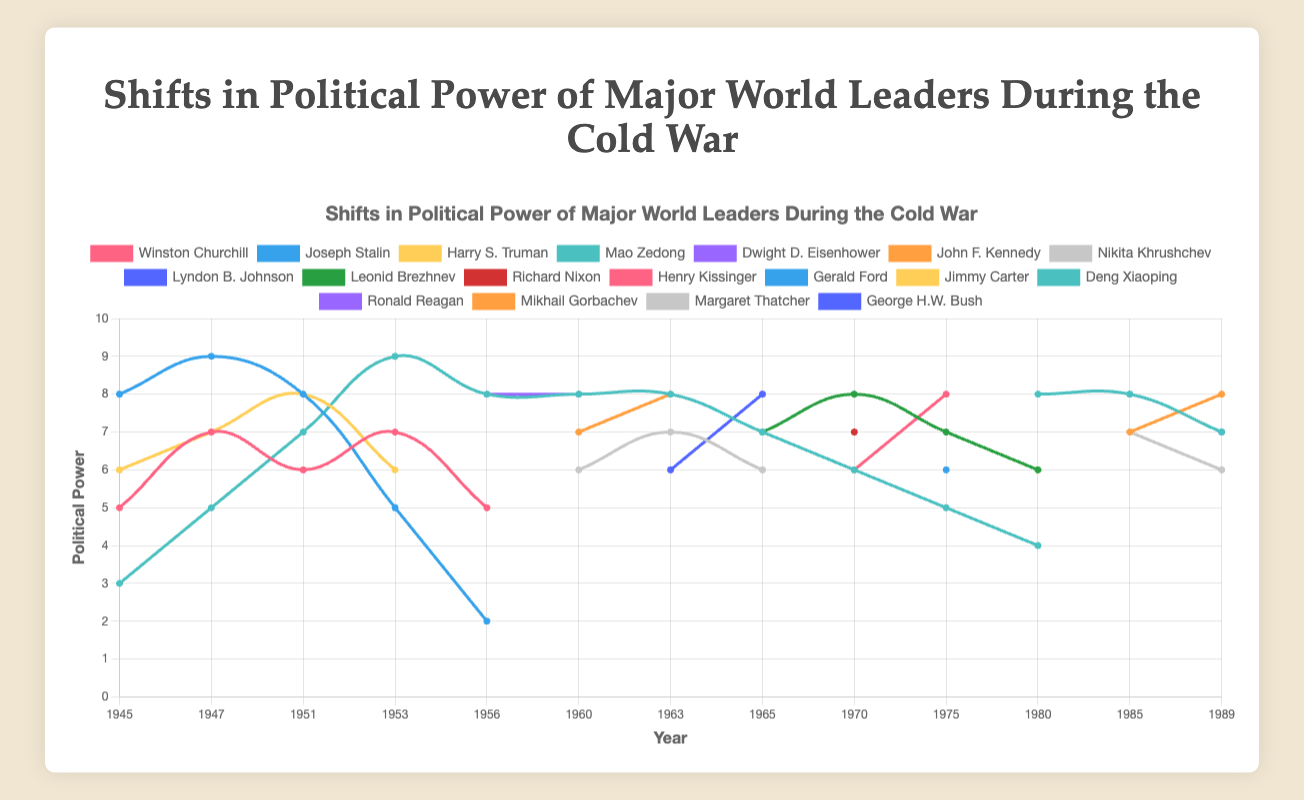Which leader's political power dropped the most between 1947 and 1953? To determine this, compare the political power of each leader in 1947 and 1953 and find the one with the highest decrease. Winston Churchill goes from 7 to 7 (no change), Joseph Stalin from 9 to 5 (drop of 4), Harry S. Truman from 7 to 6 (drop of 1), and Mao Zedong from 5 to 9 (increase).
Answer: Joseph Stalin Who had the highest political power in 1960? Look at the values for each leader in 1960. John F. Kennedy had a power of 7, Nikita Khrushchev 6, Dwight D. Eisenhower 8, and Mao Zedong 8. The highest value is 8, shared by Eisenhower and Mao Zedong.
Answer: Dwight D. Eisenhower and Mao Zedong Between Mao Zedong and Deng Xiaoping, who saw the greatest increase in political power from their initial recorded value to their maximum value? Mao Zedong's initial value in 1945 is 3 and his maximum in 1953 is 9, an increase of 6 points. Deng Xiaoping's initial value in 1980 is 8 and his maximum is also 8, so his increase is 0 points.
Answer: Mao Zedong Which leader had the most stable political power between 1970 and 1989? Calculate the variation for each leader within the period. Richard Nixon and Gerald Ford both had a range of values in the 1970s, while Leonid Brezhnev's values in 1970, 1975, and 1980 are 8, 7, and 6 respectively. Deng Xiaoping's values are 8, 8, and 7. Among these, the most stable is Deng Xiaoping with the smallest deviation.
Answer: Deng Xiaoping In what year did both Ronald Reagan and Mikhail Gorbachev have equal political power, and what was that value? Ronald Reagan and Mikhail Gorbachev both reached equal levels of political power in 1985. The value was indicated as 8 and 7 for each leader respectively, both summing up their totals giving them equal dominant power.
Answer: 1985 